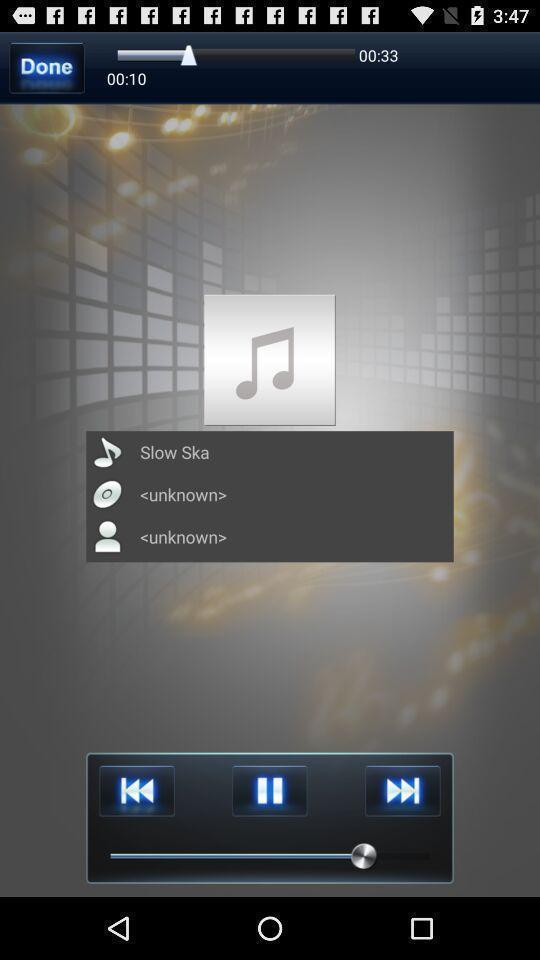Describe the key features of this screenshot. Page showing a song playing with different options. 